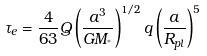<formula> <loc_0><loc_0><loc_500><loc_500>\tau _ { e } = \frac { 4 } { 6 3 } Q \left ( \frac { a ^ { 3 } } { G M _ { ^ { * } } } \right ) ^ { 1 / 2 } q \left ( \frac { a } { R _ { p l } } \right ) ^ { 5 }</formula> 